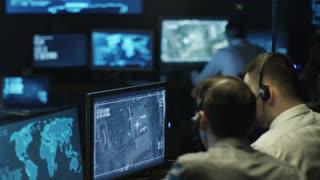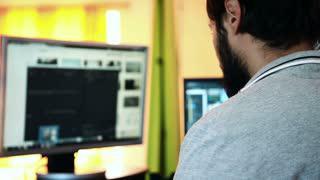The first image is the image on the left, the second image is the image on the right. Considering the images on both sides, is "In each image, a person's hands are on a laptop keyboard that has black keys on an otherwise light-colored surface." valid? Answer yes or no. No. The first image is the image on the left, the second image is the image on the right. Examine the images to the left and right. Is the description "Each image features a pair of hands over a keyboard, and the right image is an aerial view showing fingers over the black keyboard keys of one laptop." accurate? Answer yes or no. No. 